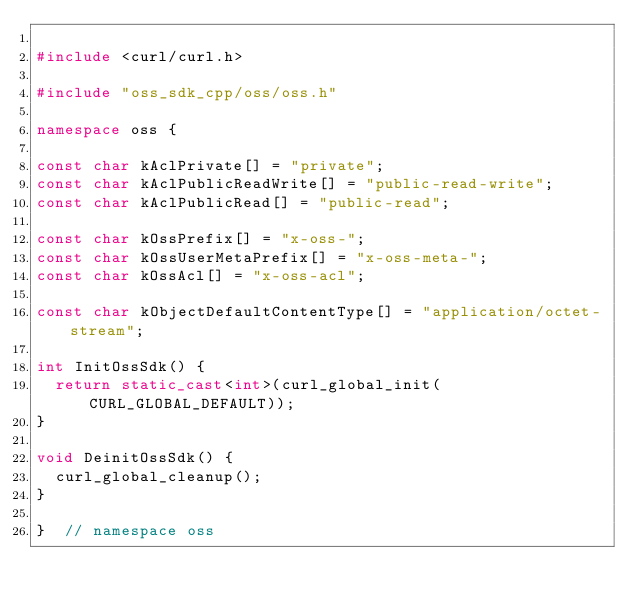Convert code to text. <code><loc_0><loc_0><loc_500><loc_500><_C++_>
#include <curl/curl.h>

#include "oss_sdk_cpp/oss/oss.h"

namespace oss {

const char kAclPrivate[] = "private";
const char kAclPublicReadWrite[] = "public-read-write";
const char kAclPublicRead[] = "public-read";

const char kOssPrefix[] = "x-oss-";
const char kOssUserMetaPrefix[] = "x-oss-meta-";
const char kOssAcl[] = "x-oss-acl";

const char kObjectDefaultContentType[] = "application/octet-stream";

int InitOssSdk() {
  return static_cast<int>(curl_global_init(CURL_GLOBAL_DEFAULT));
}

void DeinitOssSdk() {
  curl_global_cleanup();
}

}  // namespace oss
</code> 